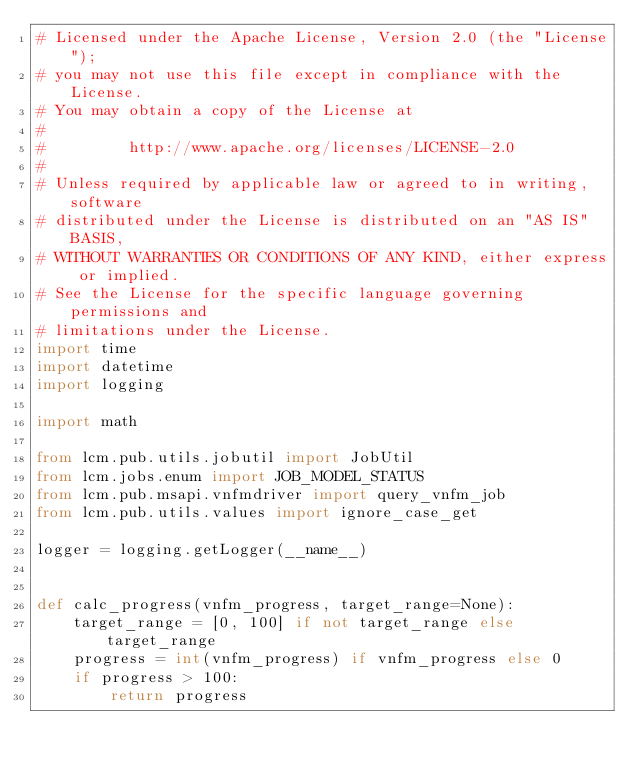Convert code to text. <code><loc_0><loc_0><loc_500><loc_500><_Python_># Licensed under the Apache License, Version 2.0 (the "License");
# you may not use this file except in compliance with the License.
# You may obtain a copy of the License at
#
#         http://www.apache.org/licenses/LICENSE-2.0
#
# Unless required by applicable law or agreed to in writing, software
# distributed under the License is distributed on an "AS IS" BASIS,
# WITHOUT WARRANTIES OR CONDITIONS OF ANY KIND, either express or implied.
# See the License for the specific language governing permissions and
# limitations under the License.
import time
import datetime
import logging

import math

from lcm.pub.utils.jobutil import JobUtil
from lcm.jobs.enum import JOB_MODEL_STATUS
from lcm.pub.msapi.vnfmdriver import query_vnfm_job
from lcm.pub.utils.values import ignore_case_get

logger = logging.getLogger(__name__)


def calc_progress(vnfm_progress, target_range=None):
    target_range = [0, 100] if not target_range else target_range
    progress = int(vnfm_progress) if vnfm_progress else 0
    if progress > 100:
        return progress</code> 